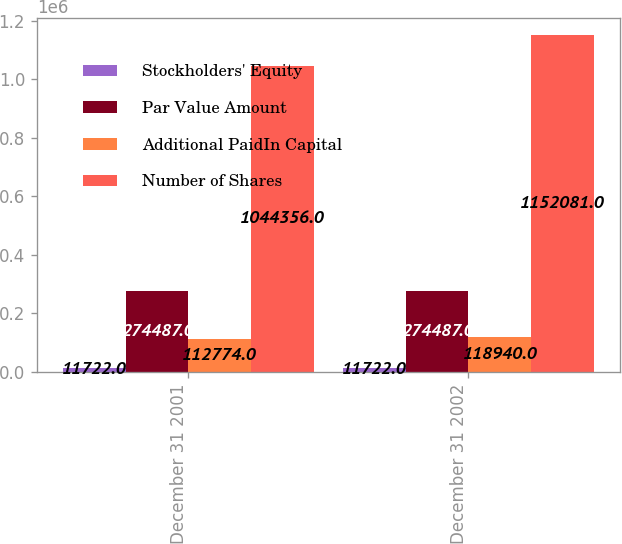Convert chart. <chart><loc_0><loc_0><loc_500><loc_500><stacked_bar_chart><ecel><fcel>December 31 2001<fcel>December 31 2002<nl><fcel>Stockholders' Equity<fcel>11722<fcel>11722<nl><fcel>Par Value Amount<fcel>274487<fcel>274487<nl><fcel>Additional PaidIn Capital<fcel>112774<fcel>118940<nl><fcel>Number of Shares<fcel>1.04436e+06<fcel>1.15208e+06<nl></chart> 